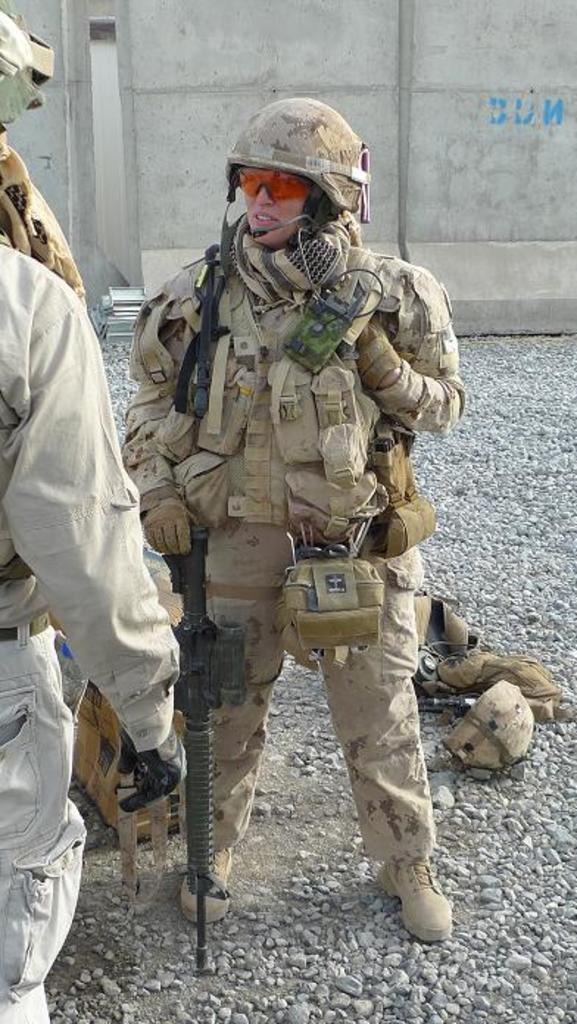In one or two sentences, can you explain what this image depicts? In this image there is a person standing and holding an object, there is a person truncated towards the left of the image, there are objects on the ground, there are stones on the ground, at the background of the image there is a wall truncated. 